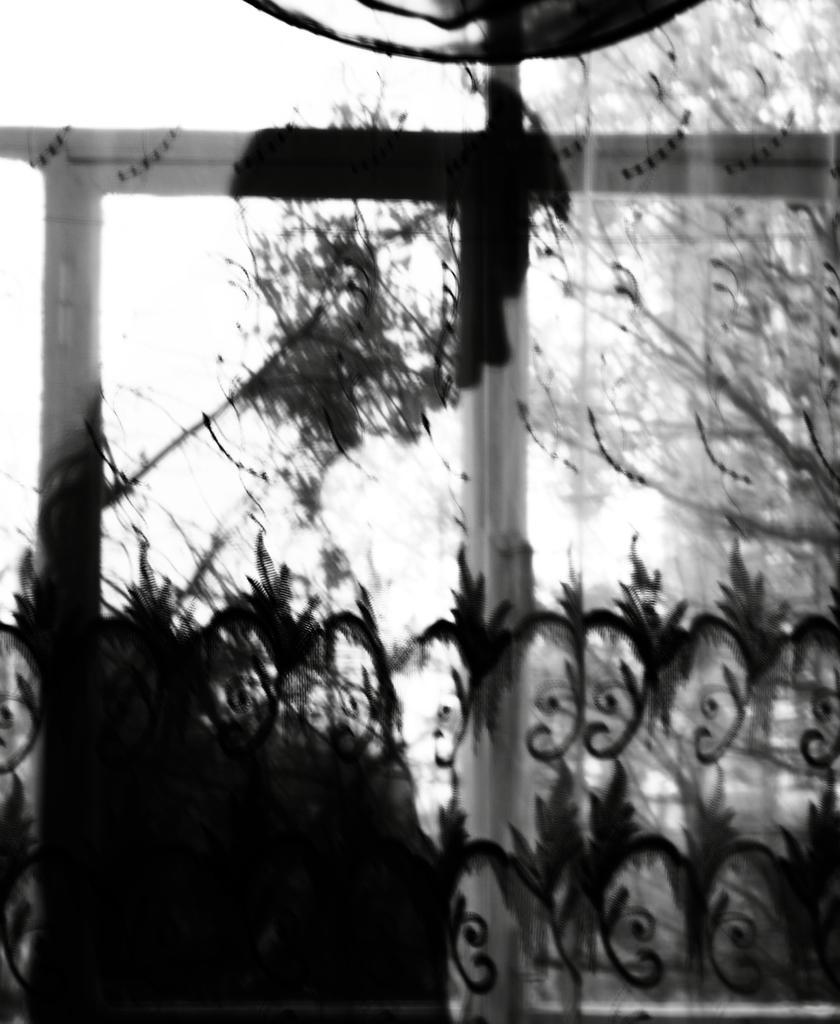Please provide a concise description of this image. In the center of the image there is a rod and trees. On the right there is a curtain. 